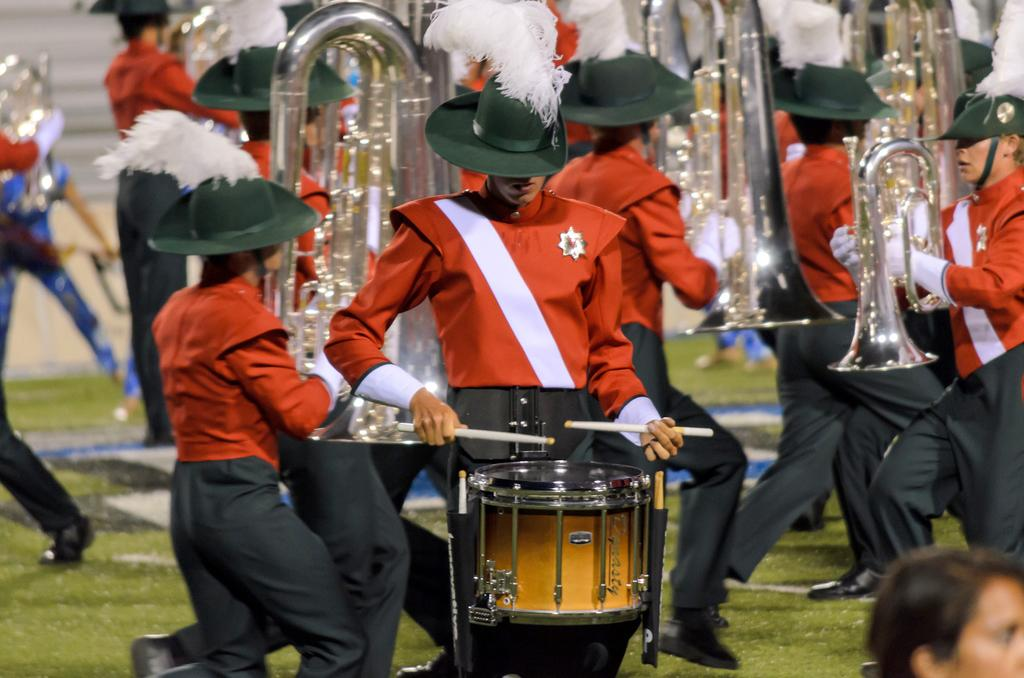What are the persons in the image doing? The persons in the image are playing musical instruments. What type of surface can be seen in the image? There is grass visible in the image. How many feet are visible in the image? There is no mention of feet in the image, as it focuses on persons playing musical instruments and the grassy surface. 